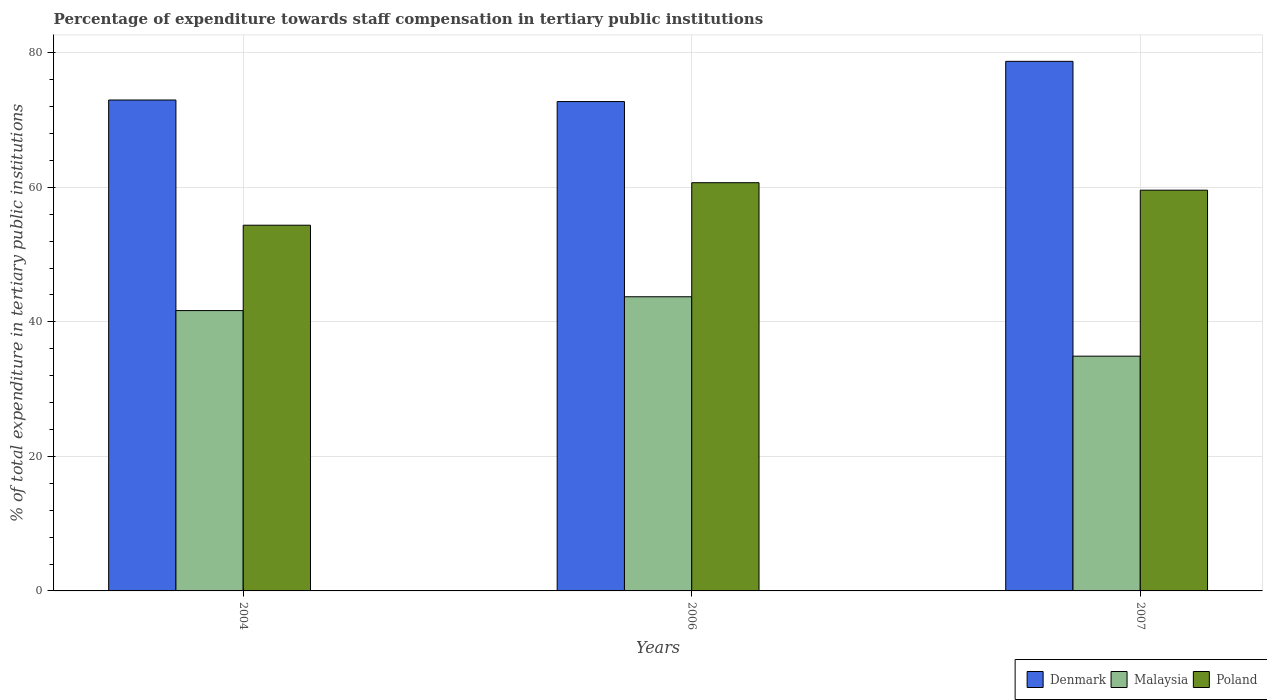How many different coloured bars are there?
Your answer should be very brief. 3. Are the number of bars per tick equal to the number of legend labels?
Make the answer very short. Yes. How many bars are there on the 3rd tick from the left?
Provide a succinct answer. 3. What is the label of the 1st group of bars from the left?
Your answer should be very brief. 2004. In how many cases, is the number of bars for a given year not equal to the number of legend labels?
Your answer should be compact. 0. What is the percentage of expenditure towards staff compensation in Denmark in 2004?
Give a very brief answer. 72.99. Across all years, what is the maximum percentage of expenditure towards staff compensation in Denmark?
Make the answer very short. 78.73. Across all years, what is the minimum percentage of expenditure towards staff compensation in Malaysia?
Your answer should be very brief. 34.9. In which year was the percentage of expenditure towards staff compensation in Denmark maximum?
Offer a very short reply. 2007. What is the total percentage of expenditure towards staff compensation in Denmark in the graph?
Keep it short and to the point. 224.47. What is the difference between the percentage of expenditure towards staff compensation in Malaysia in 2004 and that in 2007?
Offer a terse response. 6.78. What is the difference between the percentage of expenditure towards staff compensation in Poland in 2007 and the percentage of expenditure towards staff compensation in Malaysia in 2006?
Offer a very short reply. 15.85. What is the average percentage of expenditure towards staff compensation in Malaysia per year?
Offer a very short reply. 40.1. In the year 2006, what is the difference between the percentage of expenditure towards staff compensation in Poland and percentage of expenditure towards staff compensation in Denmark?
Keep it short and to the point. -12.07. What is the ratio of the percentage of expenditure towards staff compensation in Poland in 2004 to that in 2006?
Your answer should be compact. 0.9. Is the difference between the percentage of expenditure towards staff compensation in Poland in 2006 and 2007 greater than the difference between the percentage of expenditure towards staff compensation in Denmark in 2006 and 2007?
Ensure brevity in your answer.  Yes. What is the difference between the highest and the second highest percentage of expenditure towards staff compensation in Denmark?
Make the answer very short. 5.75. What is the difference between the highest and the lowest percentage of expenditure towards staff compensation in Denmark?
Offer a terse response. 5.98. Is the sum of the percentage of expenditure towards staff compensation in Denmark in 2004 and 2007 greater than the maximum percentage of expenditure towards staff compensation in Malaysia across all years?
Your answer should be compact. Yes. What does the 2nd bar from the left in 2004 represents?
Give a very brief answer. Malaysia. What does the 2nd bar from the right in 2007 represents?
Offer a terse response. Malaysia. Are all the bars in the graph horizontal?
Your response must be concise. No. How many years are there in the graph?
Give a very brief answer. 3. What is the difference between two consecutive major ticks on the Y-axis?
Offer a terse response. 20. Are the values on the major ticks of Y-axis written in scientific E-notation?
Your answer should be compact. No. Does the graph contain grids?
Provide a succinct answer. Yes. Where does the legend appear in the graph?
Provide a short and direct response. Bottom right. How are the legend labels stacked?
Offer a terse response. Horizontal. What is the title of the graph?
Keep it short and to the point. Percentage of expenditure towards staff compensation in tertiary public institutions. Does "Belgium" appear as one of the legend labels in the graph?
Ensure brevity in your answer.  No. What is the label or title of the X-axis?
Keep it short and to the point. Years. What is the label or title of the Y-axis?
Give a very brief answer. % of total expenditure in tertiary public institutions. What is the % of total expenditure in tertiary public institutions in Denmark in 2004?
Your answer should be very brief. 72.99. What is the % of total expenditure in tertiary public institutions of Malaysia in 2004?
Keep it short and to the point. 41.68. What is the % of total expenditure in tertiary public institutions in Poland in 2004?
Make the answer very short. 54.37. What is the % of total expenditure in tertiary public institutions in Denmark in 2006?
Offer a terse response. 72.76. What is the % of total expenditure in tertiary public institutions of Malaysia in 2006?
Offer a very short reply. 43.73. What is the % of total expenditure in tertiary public institutions in Poland in 2006?
Your answer should be very brief. 60.69. What is the % of total expenditure in tertiary public institutions in Denmark in 2007?
Your response must be concise. 78.73. What is the % of total expenditure in tertiary public institutions of Malaysia in 2007?
Provide a succinct answer. 34.9. What is the % of total expenditure in tertiary public institutions in Poland in 2007?
Provide a succinct answer. 59.58. Across all years, what is the maximum % of total expenditure in tertiary public institutions of Denmark?
Offer a very short reply. 78.73. Across all years, what is the maximum % of total expenditure in tertiary public institutions in Malaysia?
Your answer should be very brief. 43.73. Across all years, what is the maximum % of total expenditure in tertiary public institutions of Poland?
Ensure brevity in your answer.  60.69. Across all years, what is the minimum % of total expenditure in tertiary public institutions of Denmark?
Your answer should be very brief. 72.76. Across all years, what is the minimum % of total expenditure in tertiary public institutions of Malaysia?
Your answer should be very brief. 34.9. Across all years, what is the minimum % of total expenditure in tertiary public institutions of Poland?
Your response must be concise. 54.37. What is the total % of total expenditure in tertiary public institutions in Denmark in the graph?
Keep it short and to the point. 224.47. What is the total % of total expenditure in tertiary public institutions in Malaysia in the graph?
Provide a short and direct response. 120.31. What is the total % of total expenditure in tertiary public institutions in Poland in the graph?
Your answer should be compact. 174.64. What is the difference between the % of total expenditure in tertiary public institutions in Denmark in 2004 and that in 2006?
Your answer should be very brief. 0.23. What is the difference between the % of total expenditure in tertiary public institutions in Malaysia in 2004 and that in 2006?
Ensure brevity in your answer.  -2.05. What is the difference between the % of total expenditure in tertiary public institutions in Poland in 2004 and that in 2006?
Your answer should be compact. -6.32. What is the difference between the % of total expenditure in tertiary public institutions in Denmark in 2004 and that in 2007?
Make the answer very short. -5.75. What is the difference between the % of total expenditure in tertiary public institutions in Malaysia in 2004 and that in 2007?
Provide a succinct answer. 6.78. What is the difference between the % of total expenditure in tertiary public institutions in Poland in 2004 and that in 2007?
Your answer should be compact. -5.21. What is the difference between the % of total expenditure in tertiary public institutions in Denmark in 2006 and that in 2007?
Ensure brevity in your answer.  -5.98. What is the difference between the % of total expenditure in tertiary public institutions in Malaysia in 2006 and that in 2007?
Ensure brevity in your answer.  8.83. What is the difference between the % of total expenditure in tertiary public institutions of Poland in 2006 and that in 2007?
Your answer should be very brief. 1.11. What is the difference between the % of total expenditure in tertiary public institutions in Denmark in 2004 and the % of total expenditure in tertiary public institutions in Malaysia in 2006?
Keep it short and to the point. 29.25. What is the difference between the % of total expenditure in tertiary public institutions in Denmark in 2004 and the % of total expenditure in tertiary public institutions in Poland in 2006?
Offer a terse response. 12.3. What is the difference between the % of total expenditure in tertiary public institutions in Malaysia in 2004 and the % of total expenditure in tertiary public institutions in Poland in 2006?
Make the answer very short. -19.01. What is the difference between the % of total expenditure in tertiary public institutions of Denmark in 2004 and the % of total expenditure in tertiary public institutions of Malaysia in 2007?
Offer a terse response. 38.08. What is the difference between the % of total expenditure in tertiary public institutions in Denmark in 2004 and the % of total expenditure in tertiary public institutions in Poland in 2007?
Make the answer very short. 13.4. What is the difference between the % of total expenditure in tertiary public institutions in Malaysia in 2004 and the % of total expenditure in tertiary public institutions in Poland in 2007?
Your answer should be very brief. -17.9. What is the difference between the % of total expenditure in tertiary public institutions in Denmark in 2006 and the % of total expenditure in tertiary public institutions in Malaysia in 2007?
Provide a succinct answer. 37.85. What is the difference between the % of total expenditure in tertiary public institutions of Denmark in 2006 and the % of total expenditure in tertiary public institutions of Poland in 2007?
Offer a very short reply. 13.18. What is the difference between the % of total expenditure in tertiary public institutions of Malaysia in 2006 and the % of total expenditure in tertiary public institutions of Poland in 2007?
Your response must be concise. -15.85. What is the average % of total expenditure in tertiary public institutions in Denmark per year?
Give a very brief answer. 74.82. What is the average % of total expenditure in tertiary public institutions of Malaysia per year?
Make the answer very short. 40.1. What is the average % of total expenditure in tertiary public institutions of Poland per year?
Make the answer very short. 58.21. In the year 2004, what is the difference between the % of total expenditure in tertiary public institutions of Denmark and % of total expenditure in tertiary public institutions of Malaysia?
Provide a succinct answer. 31.31. In the year 2004, what is the difference between the % of total expenditure in tertiary public institutions of Denmark and % of total expenditure in tertiary public institutions of Poland?
Keep it short and to the point. 18.61. In the year 2004, what is the difference between the % of total expenditure in tertiary public institutions of Malaysia and % of total expenditure in tertiary public institutions of Poland?
Provide a short and direct response. -12.69. In the year 2006, what is the difference between the % of total expenditure in tertiary public institutions in Denmark and % of total expenditure in tertiary public institutions in Malaysia?
Your answer should be very brief. 29.02. In the year 2006, what is the difference between the % of total expenditure in tertiary public institutions of Denmark and % of total expenditure in tertiary public institutions of Poland?
Make the answer very short. 12.07. In the year 2006, what is the difference between the % of total expenditure in tertiary public institutions of Malaysia and % of total expenditure in tertiary public institutions of Poland?
Provide a succinct answer. -16.96. In the year 2007, what is the difference between the % of total expenditure in tertiary public institutions in Denmark and % of total expenditure in tertiary public institutions in Malaysia?
Provide a short and direct response. 43.83. In the year 2007, what is the difference between the % of total expenditure in tertiary public institutions in Denmark and % of total expenditure in tertiary public institutions in Poland?
Offer a very short reply. 19.15. In the year 2007, what is the difference between the % of total expenditure in tertiary public institutions in Malaysia and % of total expenditure in tertiary public institutions in Poland?
Ensure brevity in your answer.  -24.68. What is the ratio of the % of total expenditure in tertiary public institutions of Denmark in 2004 to that in 2006?
Provide a short and direct response. 1. What is the ratio of the % of total expenditure in tertiary public institutions in Malaysia in 2004 to that in 2006?
Offer a terse response. 0.95. What is the ratio of the % of total expenditure in tertiary public institutions in Poland in 2004 to that in 2006?
Give a very brief answer. 0.9. What is the ratio of the % of total expenditure in tertiary public institutions in Denmark in 2004 to that in 2007?
Make the answer very short. 0.93. What is the ratio of the % of total expenditure in tertiary public institutions in Malaysia in 2004 to that in 2007?
Provide a short and direct response. 1.19. What is the ratio of the % of total expenditure in tertiary public institutions in Poland in 2004 to that in 2007?
Your answer should be very brief. 0.91. What is the ratio of the % of total expenditure in tertiary public institutions of Denmark in 2006 to that in 2007?
Provide a succinct answer. 0.92. What is the ratio of the % of total expenditure in tertiary public institutions of Malaysia in 2006 to that in 2007?
Give a very brief answer. 1.25. What is the ratio of the % of total expenditure in tertiary public institutions of Poland in 2006 to that in 2007?
Keep it short and to the point. 1.02. What is the difference between the highest and the second highest % of total expenditure in tertiary public institutions of Denmark?
Your response must be concise. 5.75. What is the difference between the highest and the second highest % of total expenditure in tertiary public institutions of Malaysia?
Make the answer very short. 2.05. What is the difference between the highest and the second highest % of total expenditure in tertiary public institutions of Poland?
Keep it short and to the point. 1.11. What is the difference between the highest and the lowest % of total expenditure in tertiary public institutions of Denmark?
Give a very brief answer. 5.98. What is the difference between the highest and the lowest % of total expenditure in tertiary public institutions in Malaysia?
Your answer should be very brief. 8.83. What is the difference between the highest and the lowest % of total expenditure in tertiary public institutions in Poland?
Your response must be concise. 6.32. 